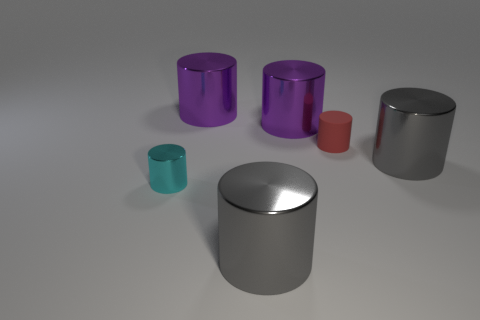Are there any other things that have the same material as the small red cylinder?
Offer a terse response. No. There is a small red thing that is the same shape as the cyan metallic object; what material is it?
Your answer should be very brief. Rubber. Are the big gray cylinder that is behind the tiny cyan metallic cylinder and the small cyan object made of the same material?
Provide a short and direct response. Yes. What shape is the tiny red thing?
Ensure brevity in your answer.  Cylinder. What is the color of the tiny cylinder that is left of the big object in front of the small cyan metallic cylinder?
Provide a short and direct response. Cyan. What size is the red matte thing behind the tiny cyan cylinder?
Make the answer very short. Small. Is there a gray cylinder made of the same material as the red object?
Your answer should be compact. No. What number of red objects are the same shape as the cyan metal thing?
Offer a terse response. 1. There is a red cylinder behind the cyan cylinder; is it the same size as the tiny shiny object?
Offer a terse response. Yes. Is the number of metal things that are on the left side of the cyan shiny cylinder greater than the number of gray cylinders that are behind the red object?
Give a very brief answer. No. 